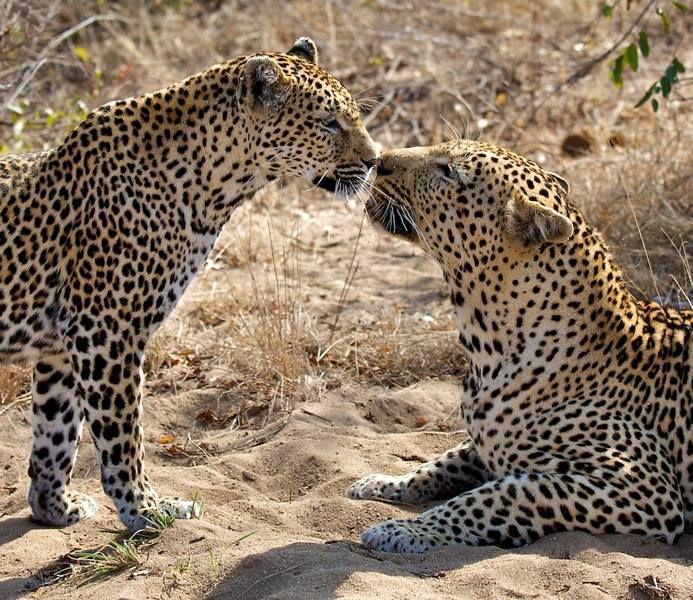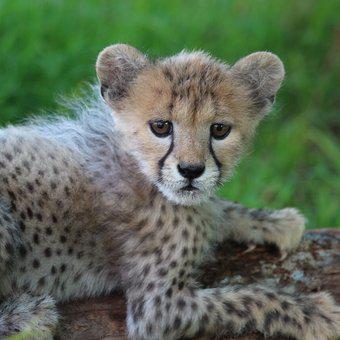The first image is the image on the left, the second image is the image on the right. For the images shown, is this caption "At least three cubs and one adult leopard are visible." true? Answer yes or no. No. The first image is the image on the left, the second image is the image on the right. Considering the images on both sides, is "The left image contains exactly three cheetahs." valid? Answer yes or no. No. 